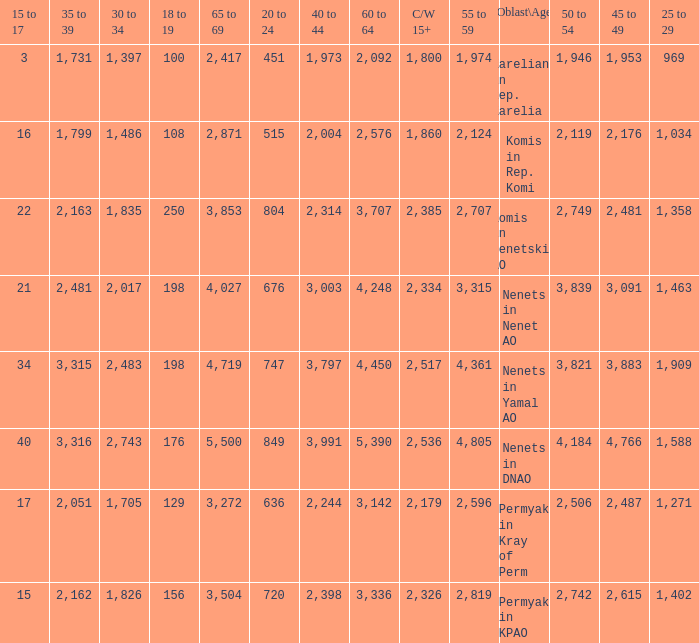What is the total 30 to 34 when the 40 to 44 is greater than 3,003, and the 50 to 54 is greater than 4,184? None. 